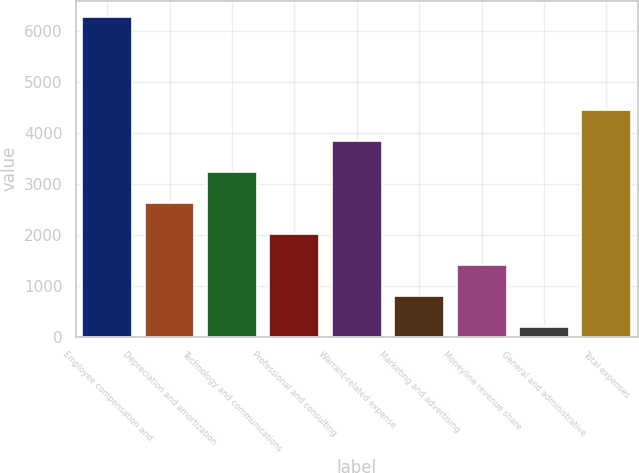Convert chart. <chart><loc_0><loc_0><loc_500><loc_500><bar_chart><fcel>Employee compensation and<fcel>Depreciation and amortization<fcel>Technology and communications<fcel>Professional and consulting<fcel>Warrant-related expense<fcel>Marketing and advertising<fcel>Moneyline revenue share<fcel>General and administrative<fcel>Total expenses<nl><fcel>6286<fcel>2626<fcel>3236<fcel>2016<fcel>3846<fcel>796<fcel>1406<fcel>186<fcel>4456<nl></chart> 